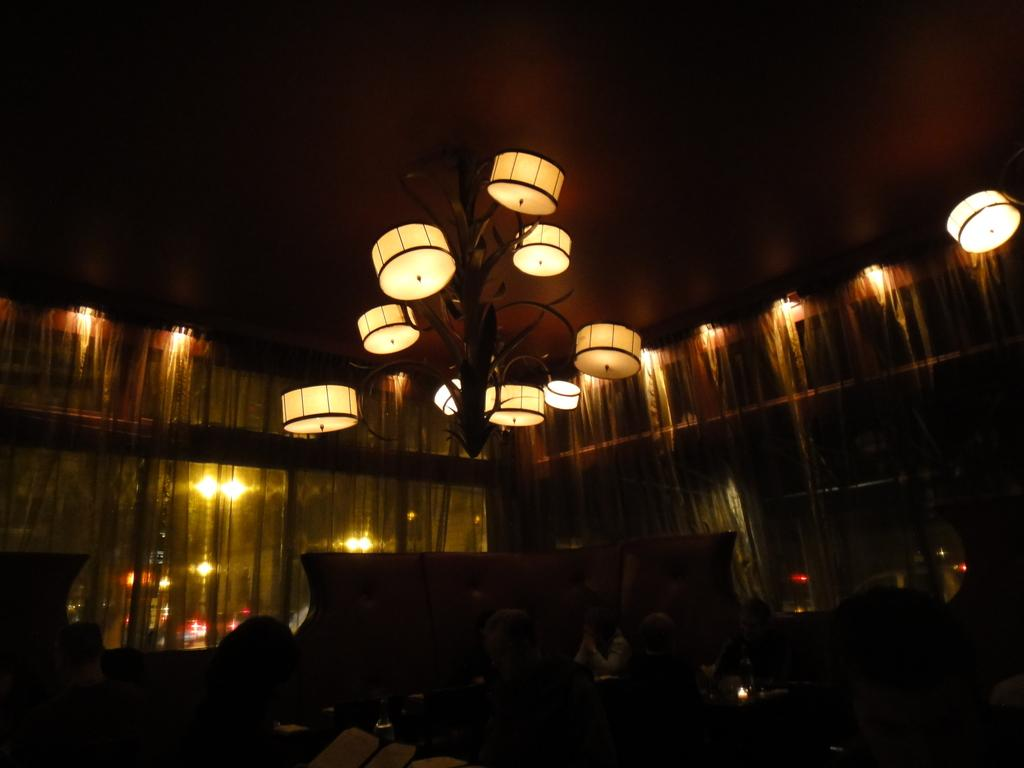What can be seen in the image that provides illumination? There are lights in the image. What type of window treatment is present in the image? There are curtains in the image. How would you describe the lighting in the bottom portion of the image? The bottom portion of the image is dark. What part of the room can be seen at the top of the image? The ceiling is visible at the top of the image. What type of toothbrush is being distributed in the image? There is no toothbrush or distribution activity present in the image. What nation is represented in the image? The image does not depict any specific nation or national symbols. 